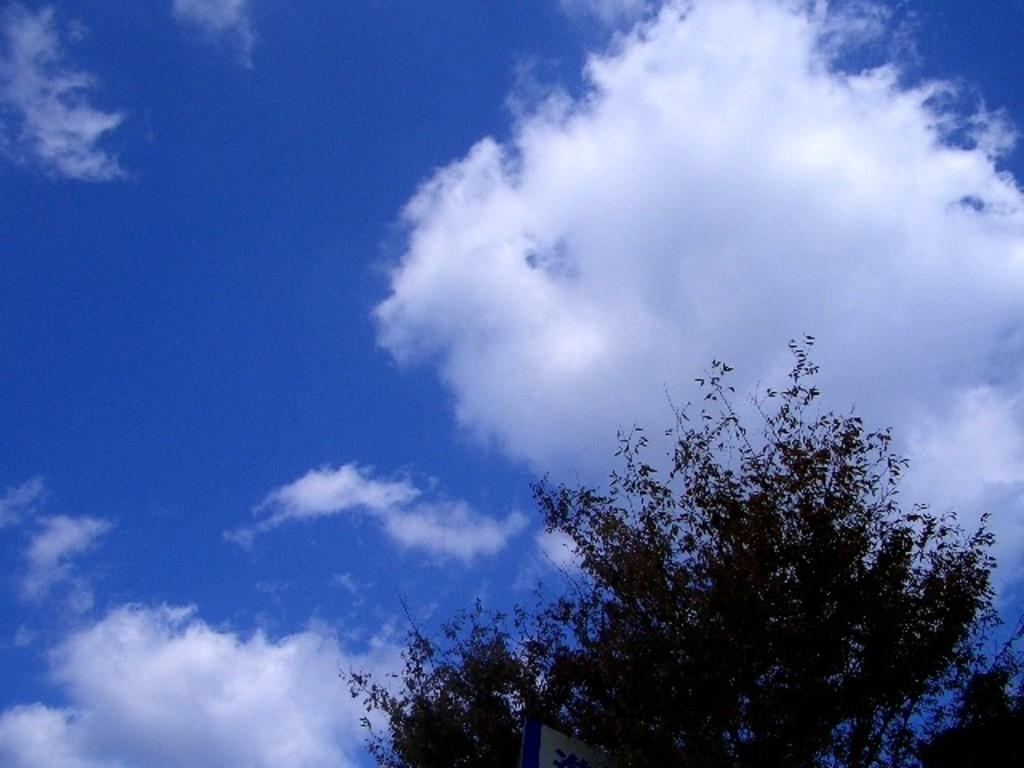What type of plant can be seen in the image? There is a tree in the image. What object is also visible in the image? There is a board in the image. What can be seen behind the tree in the image? The sky is visible behind the tree. How would you describe the weather based on the sky in the image? The sky is clear, which suggests good weather. What type of zinc is present on the list in the image? There is no list or zinc present in the image. Can you provide an example of a tree that is not visible in the image? It is not necessary to provide an example of a tree that is not visible in the image, as the conversation focuses on the tree that is present in the image. 